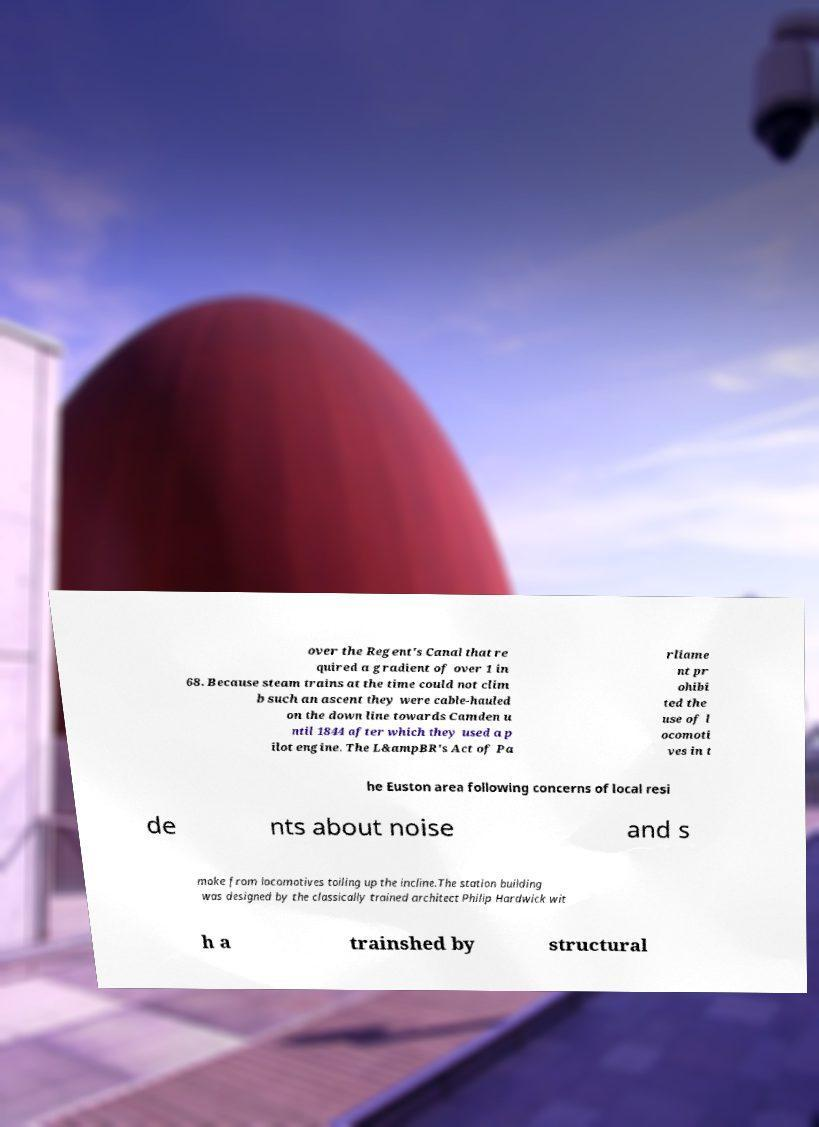Can you accurately transcribe the text from the provided image for me? over the Regent's Canal that re quired a gradient of over 1 in 68. Because steam trains at the time could not clim b such an ascent they were cable-hauled on the down line towards Camden u ntil 1844 after which they used a p ilot engine. The L&ampBR's Act of Pa rliame nt pr ohibi ted the use of l ocomoti ves in t he Euston area following concerns of local resi de nts about noise and s moke from locomotives toiling up the incline.The station building was designed by the classically trained architect Philip Hardwick wit h a trainshed by structural 